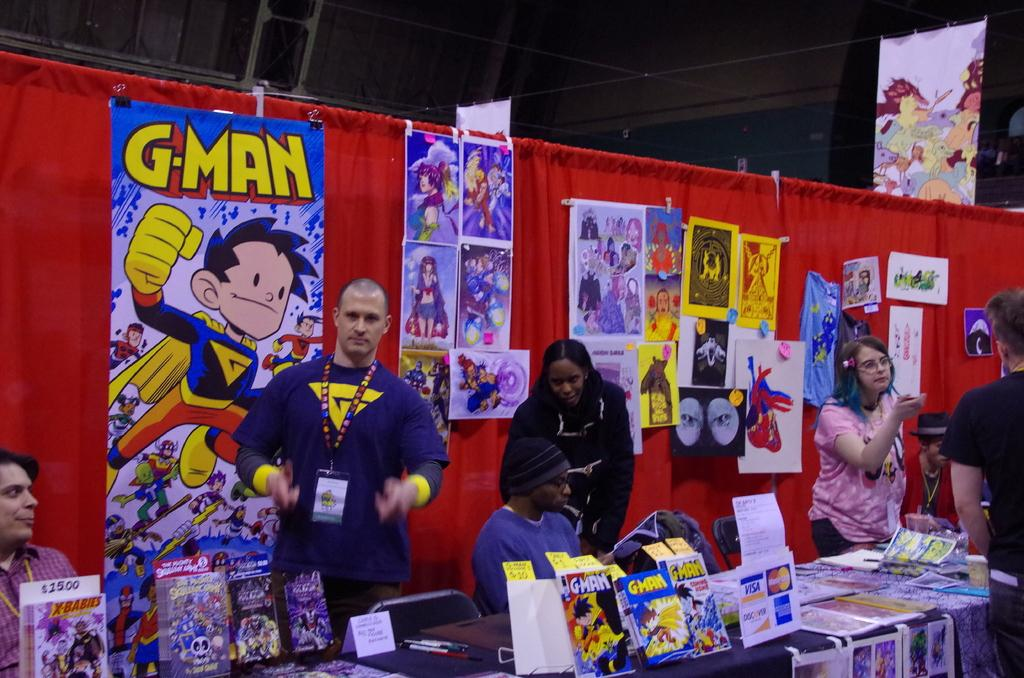<image>
Relay a brief, clear account of the picture shown. A booth at a comic convention with a poster for G-man on the wall. 